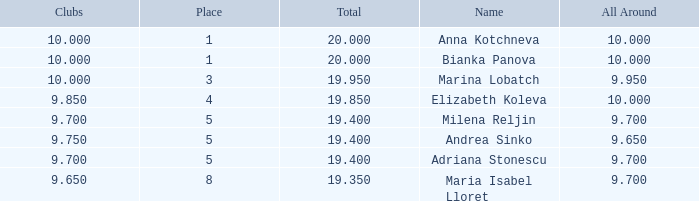What are the lowest clubs that have a place greater than 5, with an all around greater than 9.7? None. 